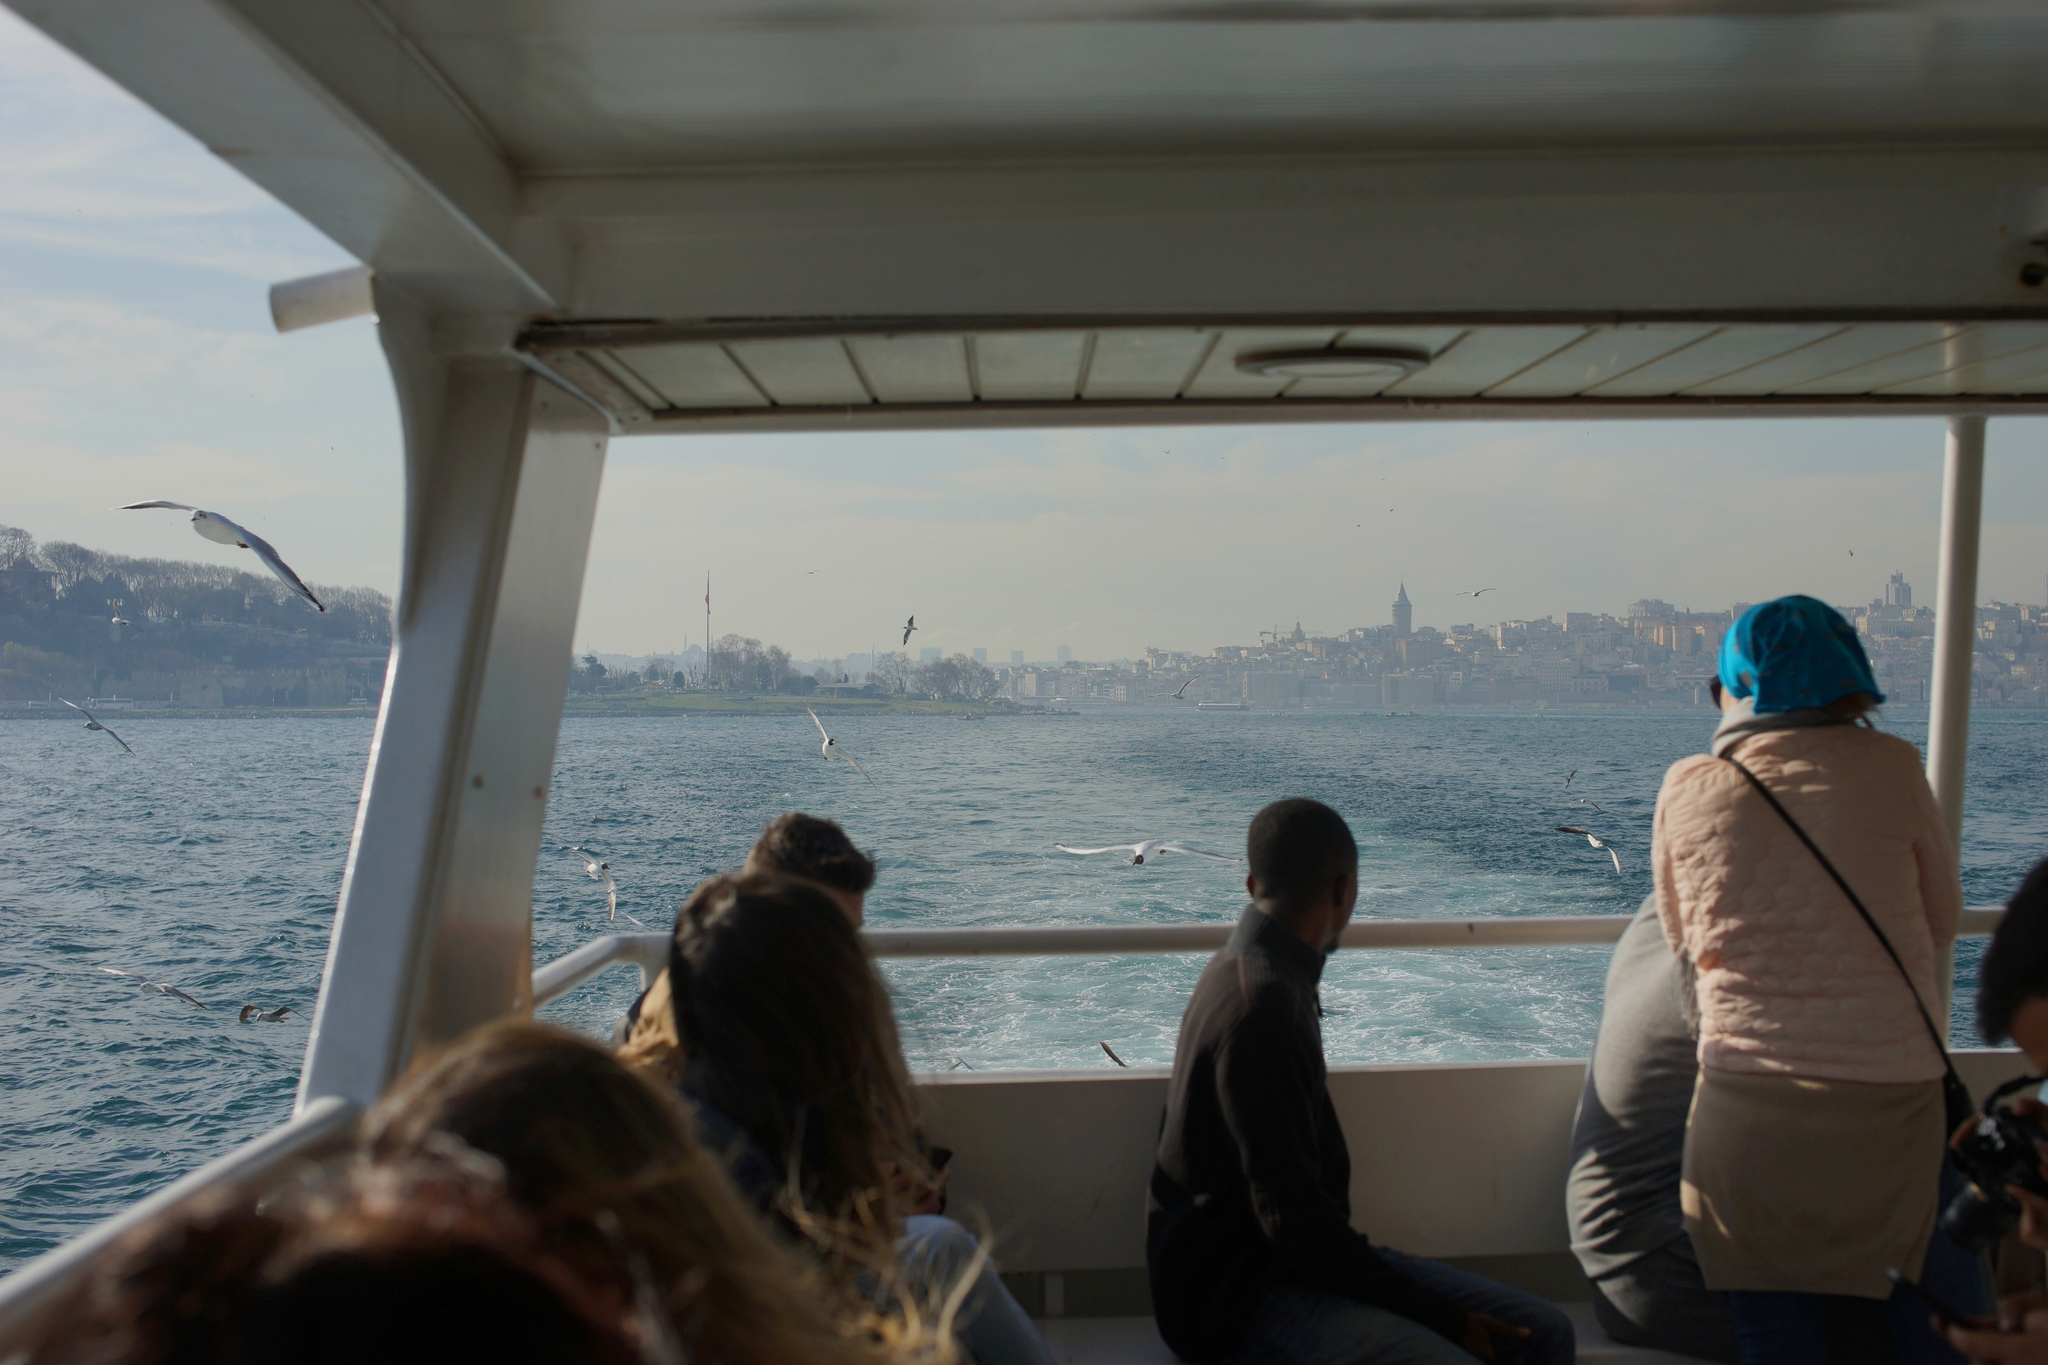What would be a more fantastical interpretation of this scene? In a more fantastical interpretation, this boat is not just any ordinary vessel, but a time-traveling ship capable of crossing dimensions. The passengers, unaware of the magical nature of their ride, are suddenly transported to a realm where the city's skyline is interwoven with mythical creatures and ancient beings. Majestic dragons soar above the minarets, and ethereal beings emerge from the water, greeting the boat with waves of iridescent light. The architecture around them shifts and changes, blending elements from various epochs and fantastical worlds, creating a mosaic of times and tales. This journey turns into an epic adventure where stories from different eras and realms come to life, challenging the passengers to uncover the mysteries of this enchanted realm while navigating the waters of time. If this scene were a still from a movie, what would the movie be about? If this image were a still from a movie, the storyline could center around a diverse group of individuals on an adventurous and introspective boat tour that inadvertently becomes a journey of self-discovery. Each passenger, coming from different walks of life, holds a unique background and set of secrets. As the boat traverses the serene waters, they encounter twists of fate, uncovering untold stories of the city that mirror their personal struggles and triumphs. Ancient legends and modern dilemmas interplay, leading the characters to confront their pasts, embrace their identities, and build unforeseen friendships. The beauty of the city and the mysteries it holds serve as a backdrop for their transformative journey, making the film an evocative tale of connection, history, and the uncharted course of human experience. What kind of emotions might the passengers be experiencing while on this boat trip? The passengers might be experiencing a spectrum of emotions during this boat trip. There is likely a sense of calm and relaxation as the journey offers a break from their daily routines, with the tranquil sea and soothing sea breeze helping them unwind. They might feel a sense of wonder and curiosity, inspired by the beautiful cityscape that blends cultural heritage with modern achievements. For some, there might be a feeling of nostalgia or romance, as the serene setting evokes memories of past experiences shared with loved ones. Others might be feeling a sense of adventure and excitement, eager to explore new horizons and capture the moment through their lenses. Overall, the boat trip is an emotional tapestry woven from tranquility, curiosity, nostalgia, and anticipation. What kind of conversations might be happening among the passengers? The conversations among the passengers might range from light-hearted and casual to profound and introspective. Friends or family members could be discussing their travel plans, sharing anecdotes from their previous adventures, or marveling at the architectural beauty and historical significance of the skyline. Some might be exchanging tips on the best local eateries, hidden gems in the city, or must-see attractions. Meanwhile, conversations among new acquaintances might center around where they are from, their reasons for visiting, and their impressions of the city so far. Others could be engaging in deeper dialogues about the blend of cultural influences seen in the skyline, reflecting on how such places shape our understanding of history and identity. There might even be quiet moments of shared appreciation, with silent nods and smiles acknowledging the serene and breathtaking experience they are collectively enjoying. 